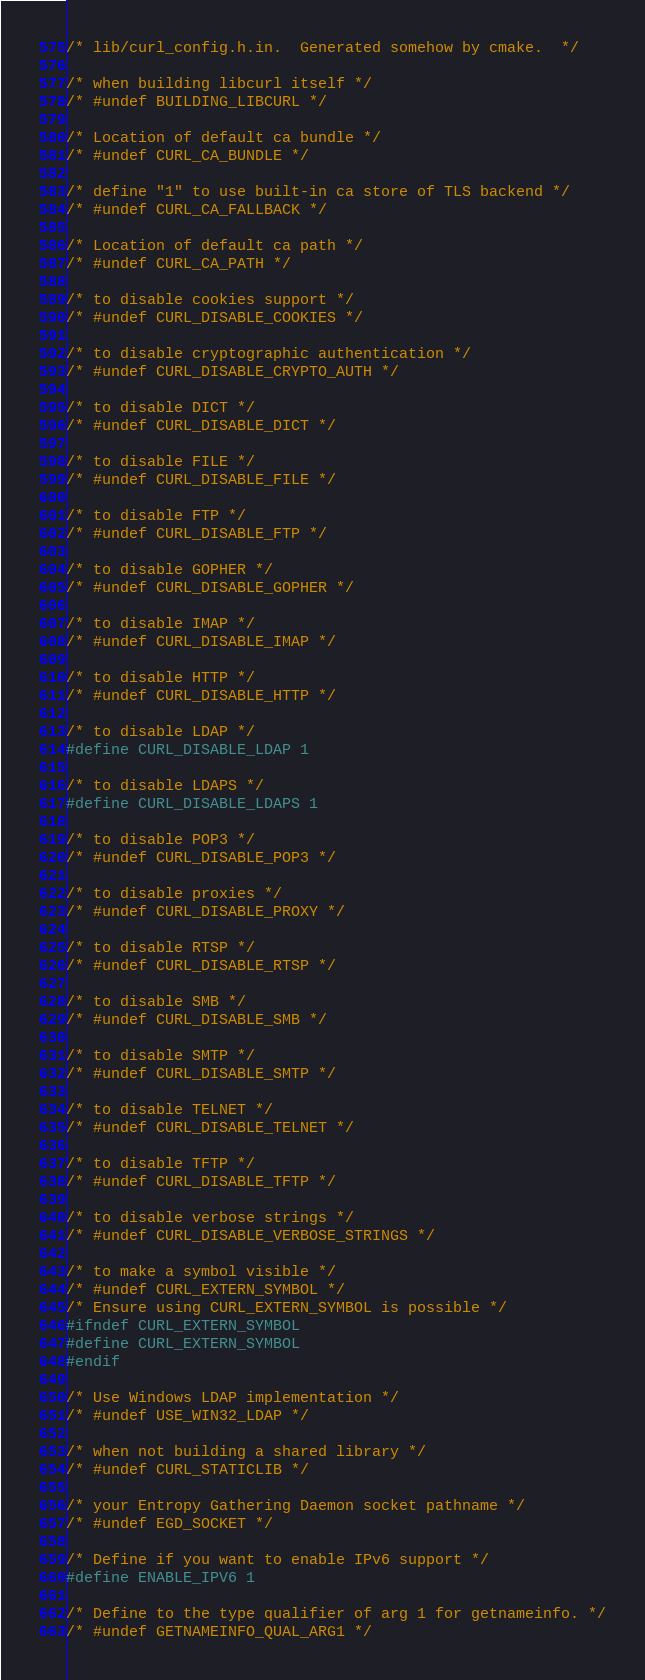<code> <loc_0><loc_0><loc_500><loc_500><_C_>/* lib/curl_config.h.in.  Generated somehow by cmake.  */

/* when building libcurl itself */
/* #undef BUILDING_LIBCURL */

/* Location of default ca bundle */
/* #undef CURL_CA_BUNDLE */

/* define "1" to use built-in ca store of TLS backend */
/* #undef CURL_CA_FALLBACK */

/* Location of default ca path */
/* #undef CURL_CA_PATH */

/* to disable cookies support */
/* #undef CURL_DISABLE_COOKIES */

/* to disable cryptographic authentication */
/* #undef CURL_DISABLE_CRYPTO_AUTH */

/* to disable DICT */
/* #undef CURL_DISABLE_DICT */

/* to disable FILE */
/* #undef CURL_DISABLE_FILE */

/* to disable FTP */
/* #undef CURL_DISABLE_FTP */

/* to disable GOPHER */
/* #undef CURL_DISABLE_GOPHER */

/* to disable IMAP */
/* #undef CURL_DISABLE_IMAP */

/* to disable HTTP */
/* #undef CURL_DISABLE_HTTP */

/* to disable LDAP */
#define CURL_DISABLE_LDAP 1

/* to disable LDAPS */
#define CURL_DISABLE_LDAPS 1

/* to disable POP3 */
/* #undef CURL_DISABLE_POP3 */

/* to disable proxies */
/* #undef CURL_DISABLE_PROXY */

/* to disable RTSP */
/* #undef CURL_DISABLE_RTSP */

/* to disable SMB */
/* #undef CURL_DISABLE_SMB */

/* to disable SMTP */
/* #undef CURL_DISABLE_SMTP */

/* to disable TELNET */
/* #undef CURL_DISABLE_TELNET */

/* to disable TFTP */
/* #undef CURL_DISABLE_TFTP */

/* to disable verbose strings */
/* #undef CURL_DISABLE_VERBOSE_STRINGS */

/* to make a symbol visible */
/* #undef CURL_EXTERN_SYMBOL */
/* Ensure using CURL_EXTERN_SYMBOL is possible */
#ifndef CURL_EXTERN_SYMBOL
#define CURL_EXTERN_SYMBOL
#endif

/* Use Windows LDAP implementation */
/* #undef USE_WIN32_LDAP */

/* when not building a shared library */
/* #undef CURL_STATICLIB */

/* your Entropy Gathering Daemon socket pathname */
/* #undef EGD_SOCKET */

/* Define if you want to enable IPv6 support */
#define ENABLE_IPV6 1

/* Define to the type qualifier of arg 1 for getnameinfo. */
/* #undef GETNAMEINFO_QUAL_ARG1 */
</code> 